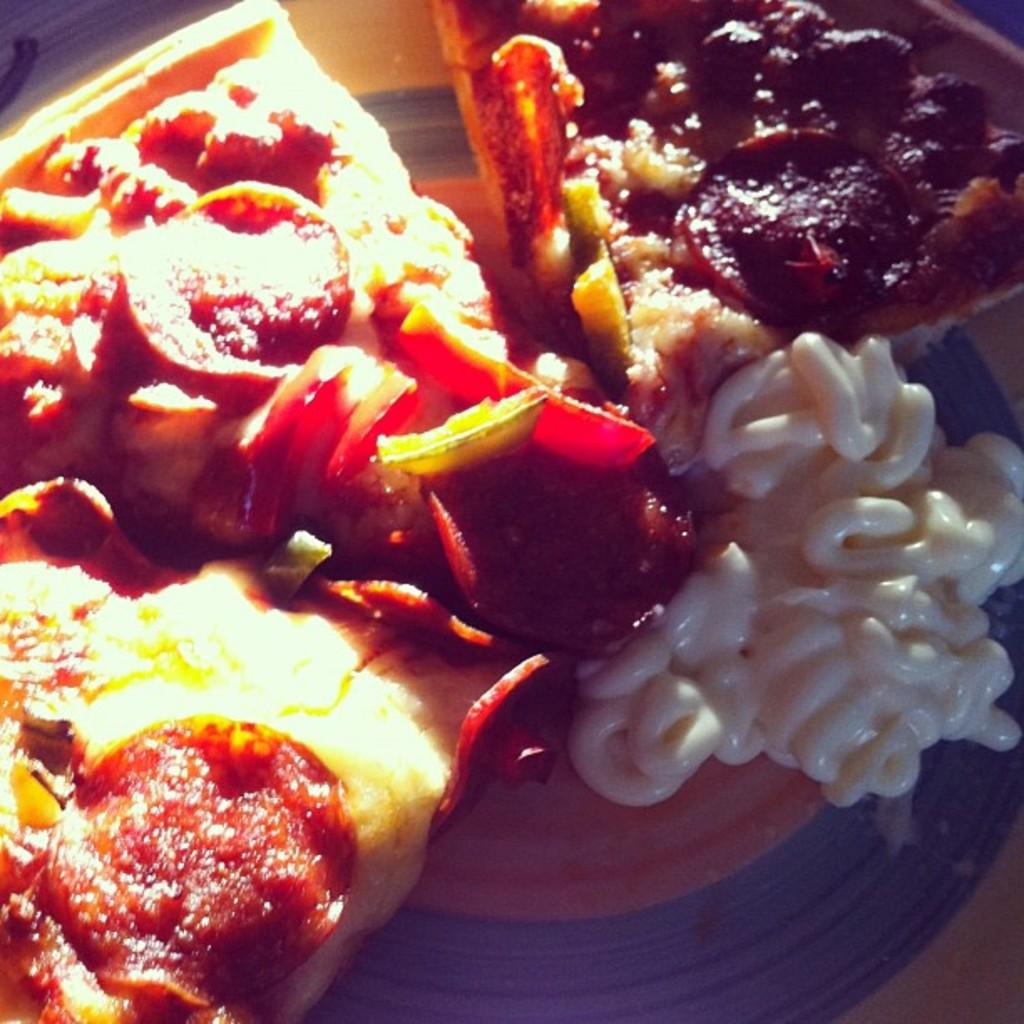What is on the serving plate in the image? The serving plate contains slices of pizza. Is there anything else on the serving plate besides the pizza? Yes, there is mayonnaise on the serving plate. What type of plastic material is used to make the feet of the actor in the image? There is no actor or feet present in the image; it features a serving plate with pizza and mayonnaise. 